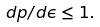Convert formula to latex. <formula><loc_0><loc_0><loc_500><loc_500>d p / d \epsilon \leq 1 .</formula> 